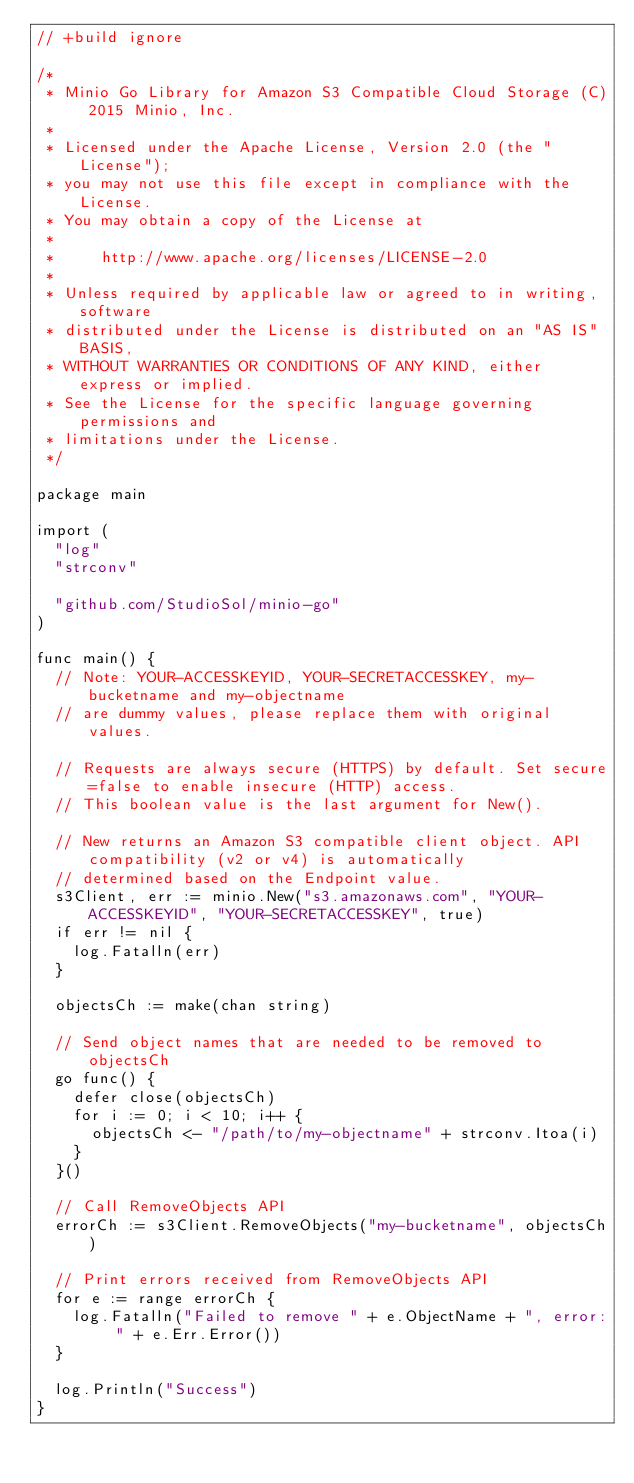Convert code to text. <code><loc_0><loc_0><loc_500><loc_500><_Go_>// +build ignore

/*
 * Minio Go Library for Amazon S3 Compatible Cloud Storage (C) 2015 Minio, Inc.
 *
 * Licensed under the Apache License, Version 2.0 (the "License");
 * you may not use this file except in compliance with the License.
 * You may obtain a copy of the License at
 *
 *     http://www.apache.org/licenses/LICENSE-2.0
 *
 * Unless required by applicable law or agreed to in writing, software
 * distributed under the License is distributed on an "AS IS" BASIS,
 * WITHOUT WARRANTIES OR CONDITIONS OF ANY KIND, either express or implied.
 * See the License for the specific language governing permissions and
 * limitations under the License.
 */

package main

import (
	"log"
	"strconv"

	"github.com/StudioSol/minio-go"
)

func main() {
	// Note: YOUR-ACCESSKEYID, YOUR-SECRETACCESSKEY, my-bucketname and my-objectname
	// are dummy values, please replace them with original values.

	// Requests are always secure (HTTPS) by default. Set secure=false to enable insecure (HTTP) access.
	// This boolean value is the last argument for New().

	// New returns an Amazon S3 compatible client object. API compatibility (v2 or v4) is automatically
	// determined based on the Endpoint value.
	s3Client, err := minio.New("s3.amazonaws.com", "YOUR-ACCESSKEYID", "YOUR-SECRETACCESSKEY", true)
	if err != nil {
		log.Fatalln(err)
	}

	objectsCh := make(chan string)

	// Send object names that are needed to be removed to objectsCh
	go func() {
		defer close(objectsCh)
		for i := 0; i < 10; i++ {
			objectsCh <- "/path/to/my-objectname" + strconv.Itoa(i)
		}
	}()

	// Call RemoveObjects API
	errorCh := s3Client.RemoveObjects("my-bucketname", objectsCh)

	// Print errors received from RemoveObjects API
	for e := range errorCh {
		log.Fatalln("Failed to remove " + e.ObjectName + ", error: " + e.Err.Error())
	}

	log.Println("Success")
}
</code> 